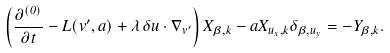Convert formula to latex. <formula><loc_0><loc_0><loc_500><loc_500>\left ( \frac { \partial ^ { ( 0 ) } } { \partial t } - L ( v ^ { \prime } , a ) + \lambda \, \delta { u \cdot \nabla } _ { { v } ^ { \prime } } \right ) X _ { \beta , k } - a X _ { u _ { x } , k } \delta _ { \beta , u _ { y } } = - Y _ { \beta , k } .</formula> 